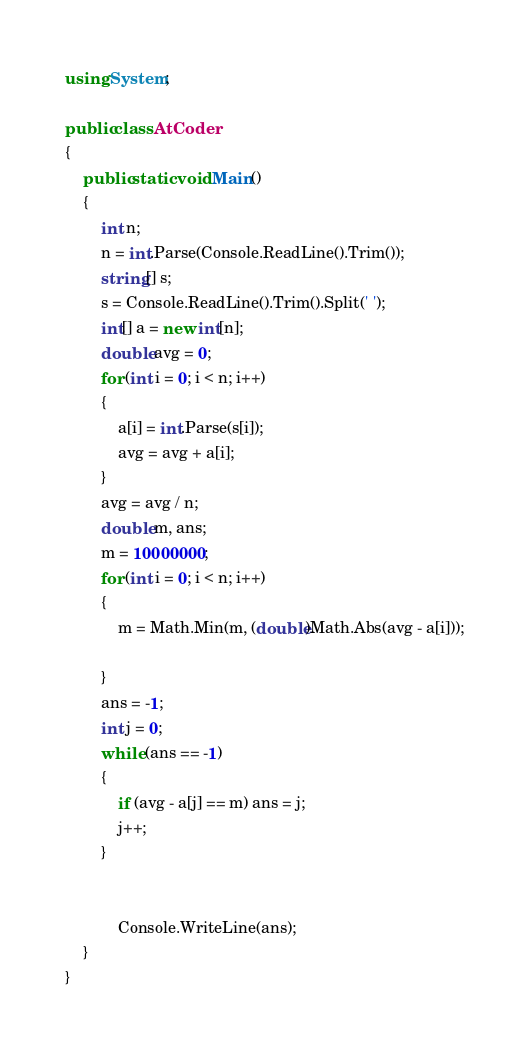<code> <loc_0><loc_0><loc_500><loc_500><_C#_>using System;

public class AtCoder
{
    public static void Main()
    {
        int n;
        n = int.Parse(Console.ReadLine().Trim());
        string[] s;
        s = Console.ReadLine().Trim().Split(' ');
        int[] a = new int[n];
        double avg = 0;
        for (int i = 0; i < n; i++)
        {
            a[i] = int.Parse(s[i]);
            avg = avg + a[i];
        }
        avg = avg / n;
        double m, ans;
        m = 10000000;
        for (int i = 0; i < n; i++)
        {
            m = Math.Min(m, (double)Math.Abs(avg - a[i]));
            
        }
        ans = -1;
        int j = 0;
        while (ans == -1)
        {
            if (avg - a[j] == m) ans = j;
            j++;
        }


            Console.WriteLine(ans);
    }
}
</code> 